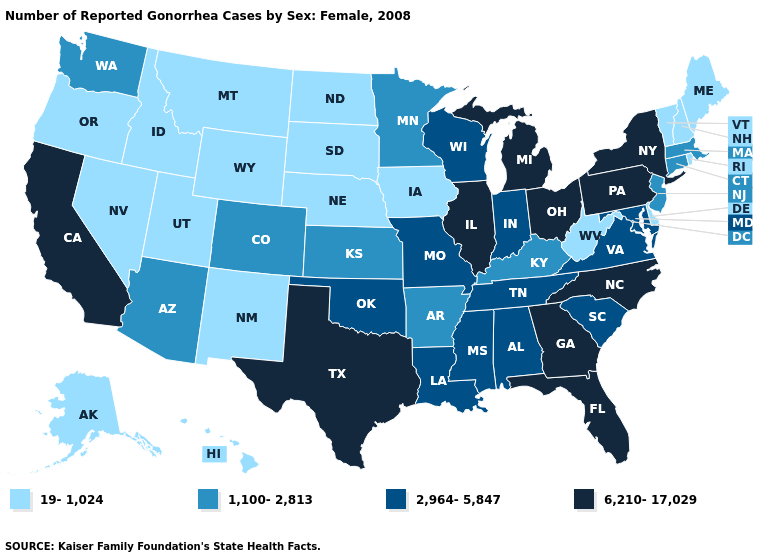Does Pennsylvania have the highest value in the Northeast?
Write a very short answer. Yes. Does Kentucky have a lower value than Tennessee?
Give a very brief answer. Yes. Name the states that have a value in the range 19-1,024?
Concise answer only. Alaska, Delaware, Hawaii, Idaho, Iowa, Maine, Montana, Nebraska, Nevada, New Hampshire, New Mexico, North Dakota, Oregon, Rhode Island, South Dakota, Utah, Vermont, West Virginia, Wyoming. What is the value of Missouri?
Be succinct. 2,964-5,847. What is the lowest value in the USA?
Keep it brief. 19-1,024. What is the value of Wisconsin?
Quick response, please. 2,964-5,847. Among the states that border Colorado , which have the lowest value?
Answer briefly. Nebraska, New Mexico, Utah, Wyoming. What is the lowest value in states that border Missouri?
Keep it brief. 19-1,024. What is the highest value in the USA?
Give a very brief answer. 6,210-17,029. Which states have the lowest value in the USA?
Keep it brief. Alaska, Delaware, Hawaii, Idaho, Iowa, Maine, Montana, Nebraska, Nevada, New Hampshire, New Mexico, North Dakota, Oregon, Rhode Island, South Dakota, Utah, Vermont, West Virginia, Wyoming. Name the states that have a value in the range 6,210-17,029?
Keep it brief. California, Florida, Georgia, Illinois, Michigan, New York, North Carolina, Ohio, Pennsylvania, Texas. Name the states that have a value in the range 6,210-17,029?
Write a very short answer. California, Florida, Georgia, Illinois, Michigan, New York, North Carolina, Ohio, Pennsylvania, Texas. Does New Mexico have a lower value than West Virginia?
Keep it brief. No. Name the states that have a value in the range 6,210-17,029?
Concise answer only. California, Florida, Georgia, Illinois, Michigan, New York, North Carolina, Ohio, Pennsylvania, Texas. Does Tennessee have the highest value in the South?
Quick response, please. No. 